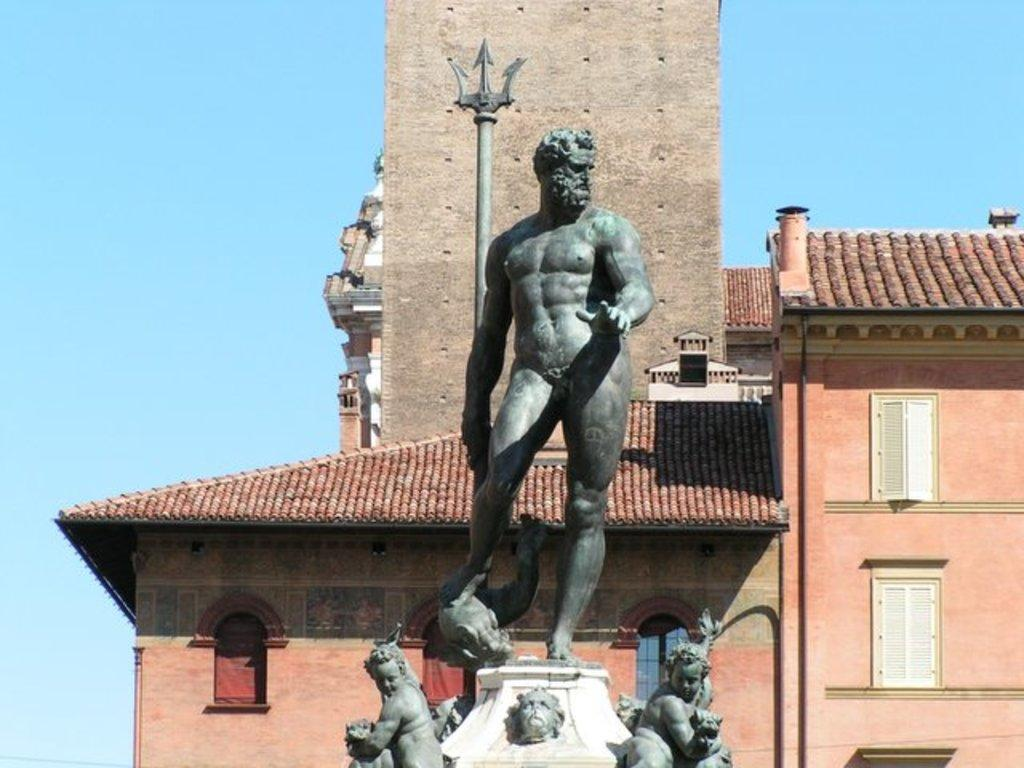What can you describe the statues in the image? There are statues in the image, and they are gray in color. What can be seen in the background of the image? There is a building in the background of the image, and it is brown in color. What is the color of the sky in the image? The sky is blue in color. What type of sack can be seen being carried by the statues in the image? There are no sacks present in the image, as the statues are not carrying anything. What kind of experience can be gained by visiting the location depicted in the image? The image does not provide enough information to determine what kind of experience one might have by visiting the location. 